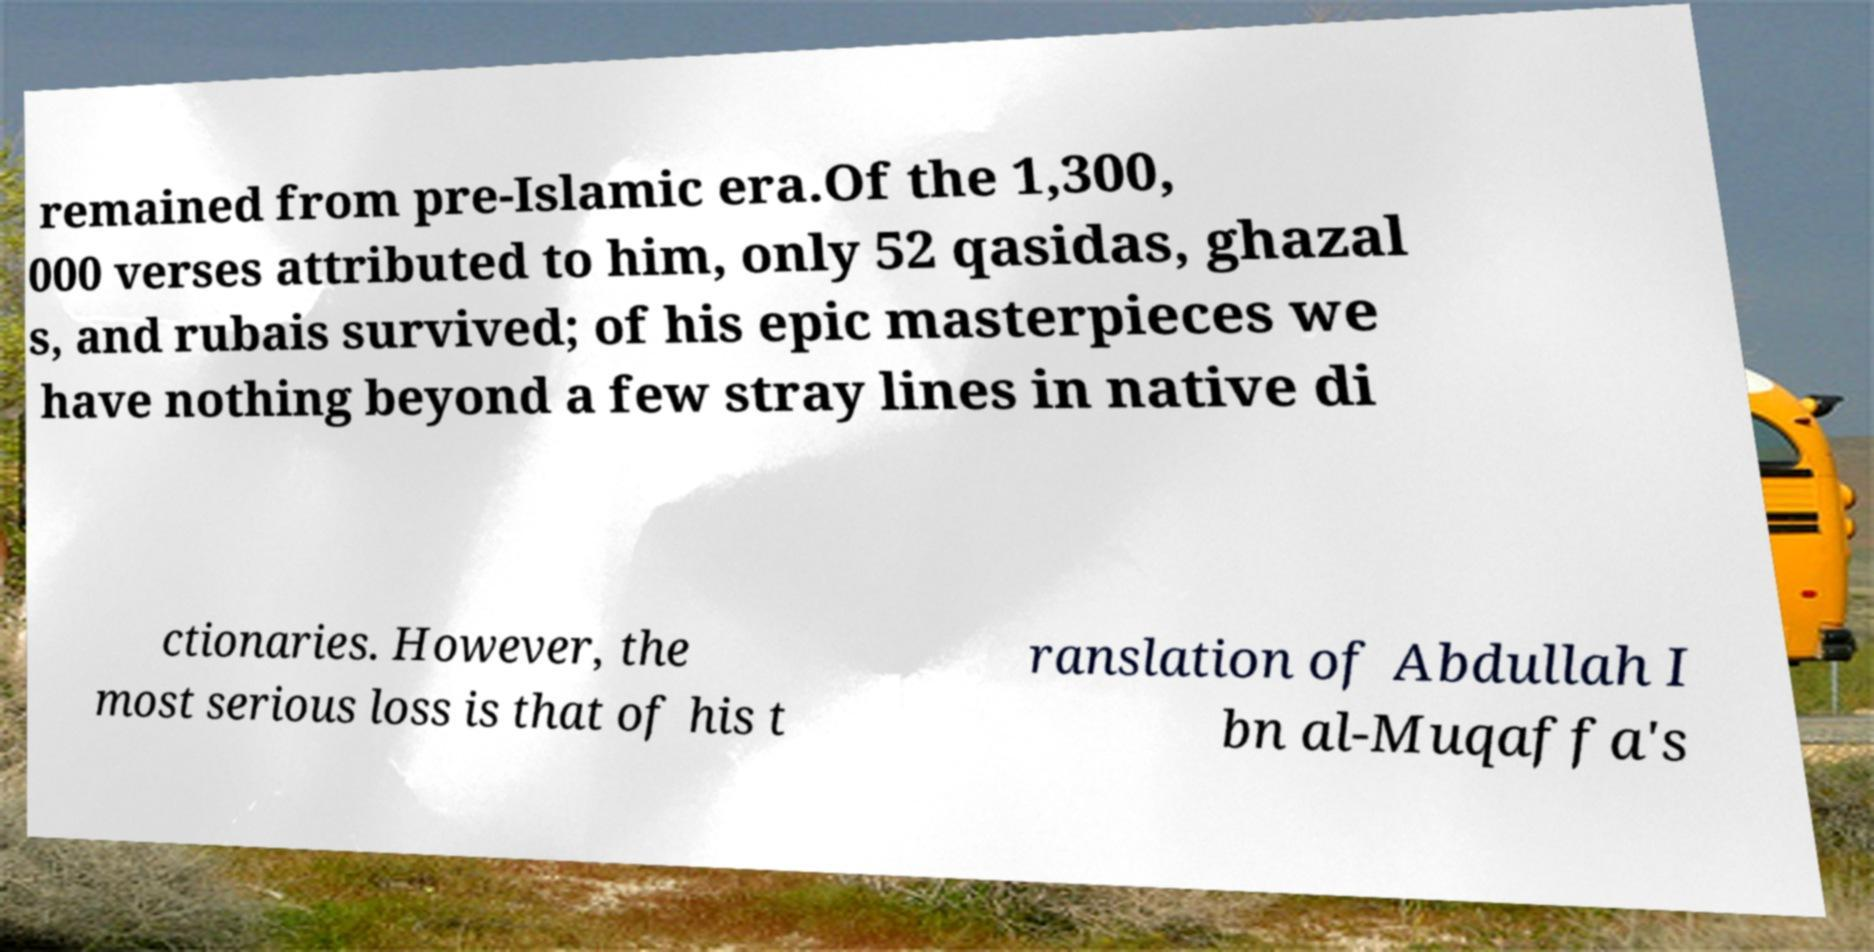Could you extract and type out the text from this image? remained from pre-Islamic era.Of the 1,300, 000 verses attributed to him, only 52 qasidas, ghazal s, and rubais survived; of his epic masterpieces we have nothing beyond a few stray lines in native di ctionaries. However, the most serious loss is that of his t ranslation of Abdullah I bn al-Muqaffa's 